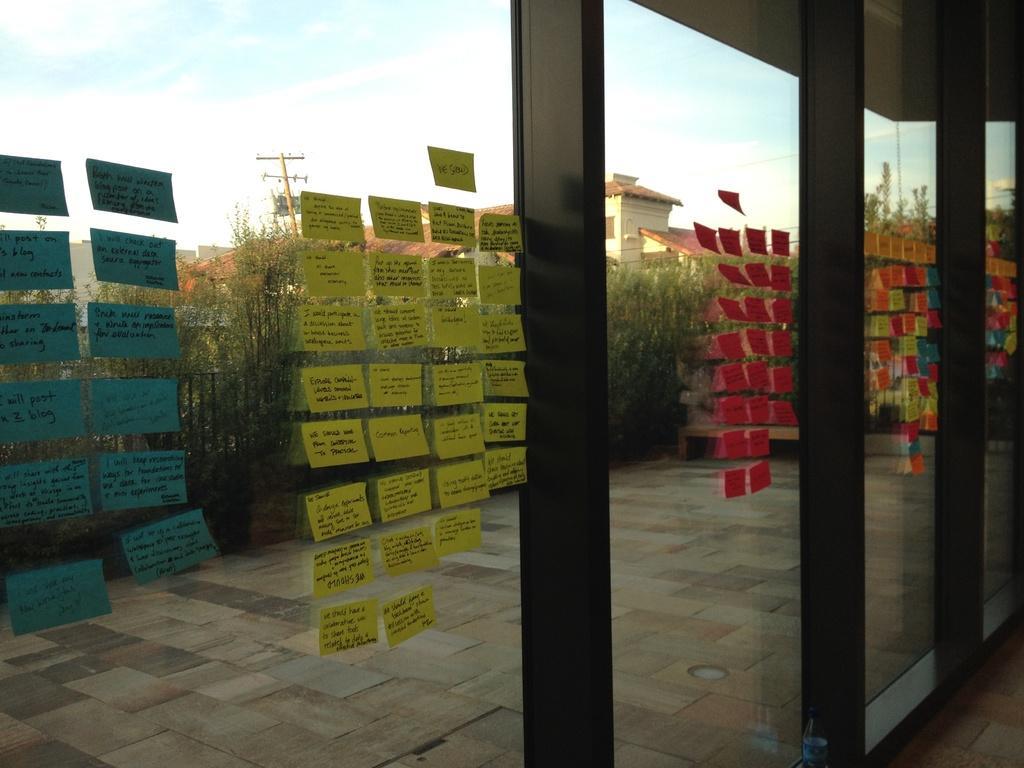Describe this image in one or two sentences. In this picture we can see many colorful sticky notes on the glass window panes. In the background, we can see trees and houses. 